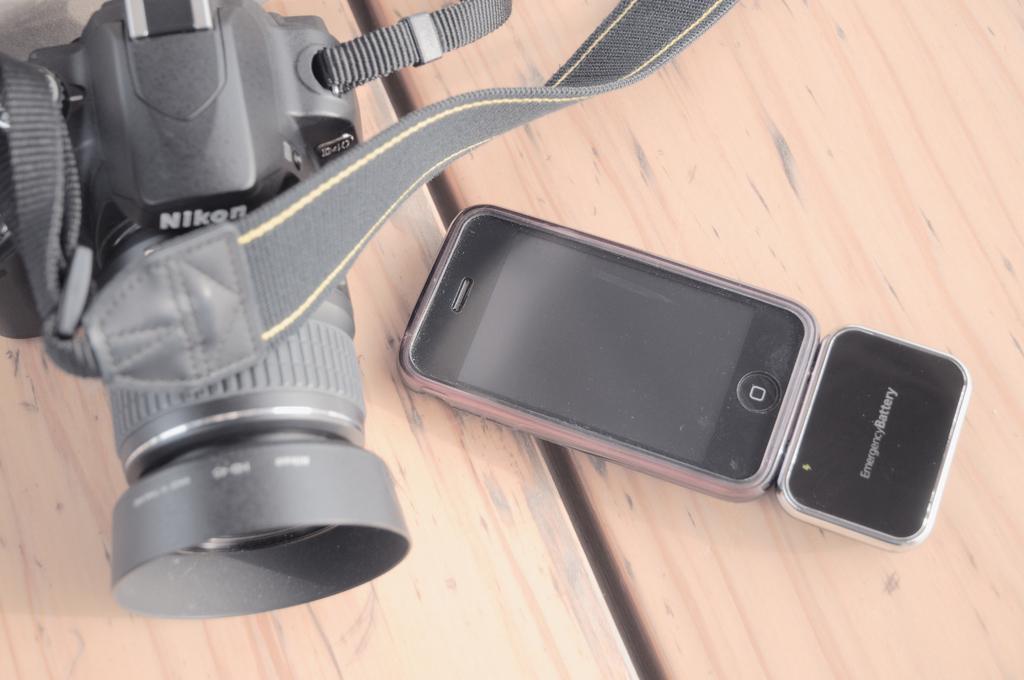Describe this image in one or two sentences. In the left side it is a camera, which is in black color and here it is an i phone. 